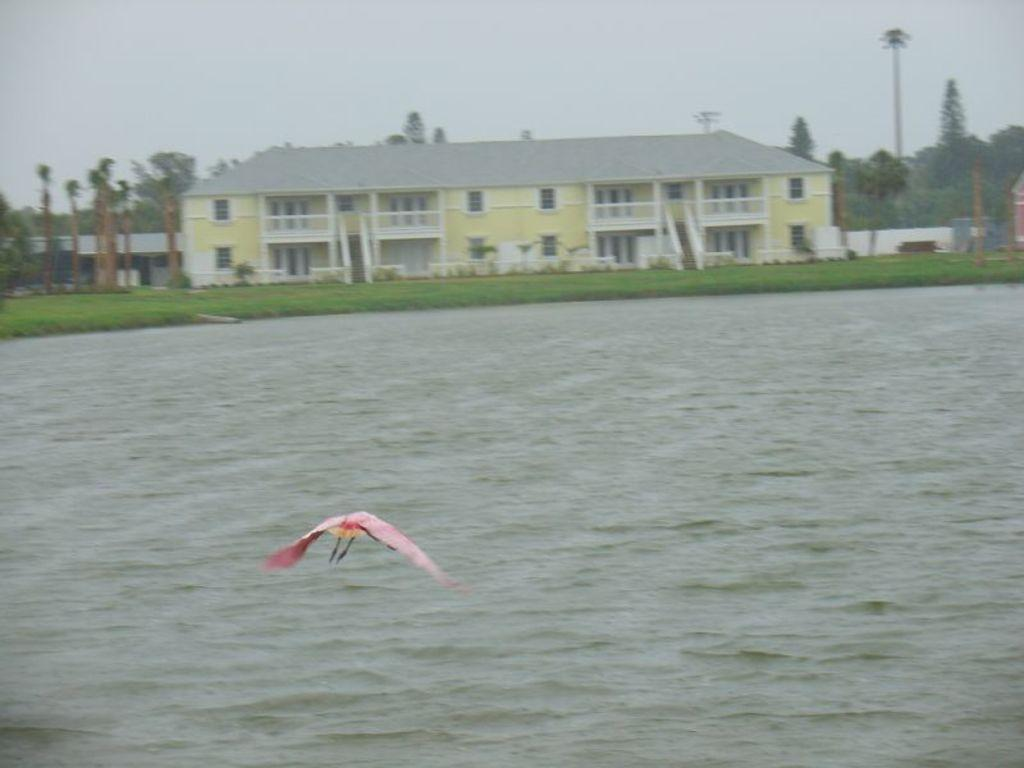What is the bird doing in the image? The bird is flying in the air. What can be seen below the bird? There is water visible in the image. What type of vegetation is present in the image? There is grass in the image. What is visible in the background of the image? There are trees, a building, a pole, and the sky visible in the background of the image. What country is the bird flying over in the image? The image does not provide any information about the country where the bird is flying. Where is the best spot to see the bird in the image? The bird is flying in the air, so there is no specific spot to see it in the image. 